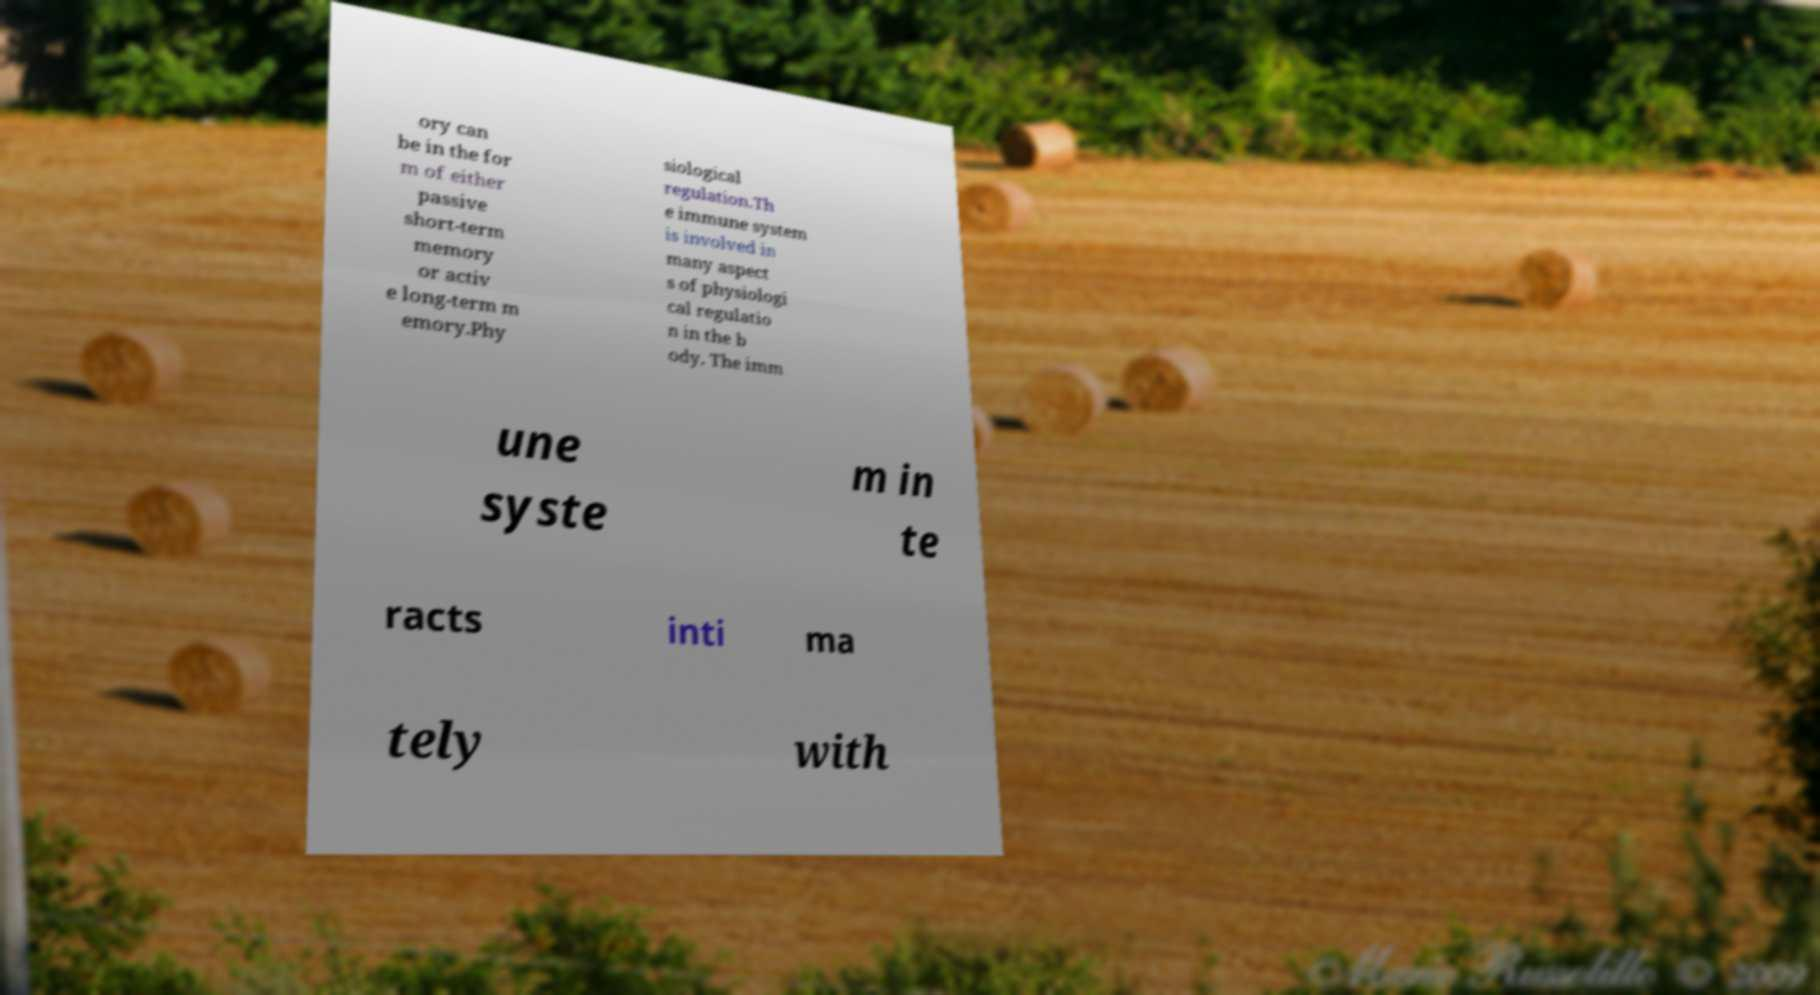Can you accurately transcribe the text from the provided image for me? ory can be in the for m of either passive short-term memory or activ e long-term m emory.Phy siological regulation.Th e immune system is involved in many aspect s of physiologi cal regulatio n in the b ody. The imm une syste m in te racts inti ma tely with 